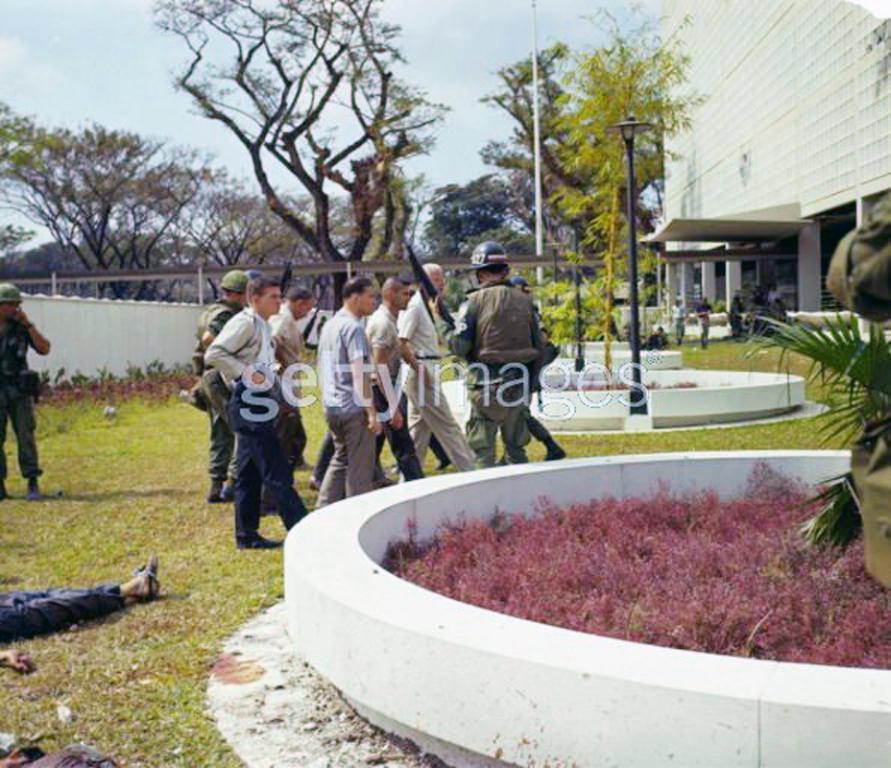Describe this image in one or two sentences. In this image I can see few people, poles, buildings, trees, few objects and the sky. 